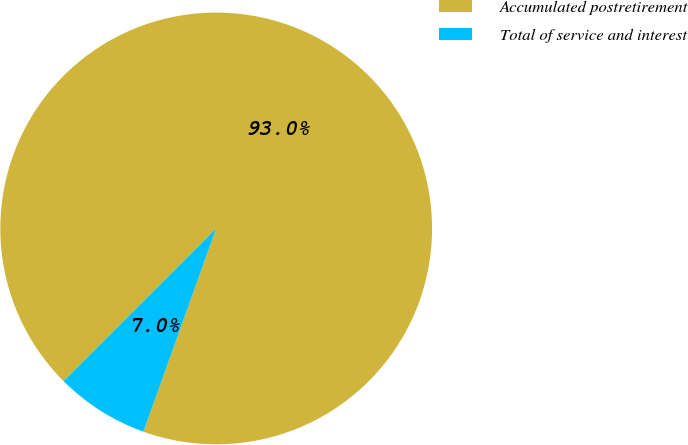<chart> <loc_0><loc_0><loc_500><loc_500><pie_chart><fcel>Accumulated postretirement<fcel>Total of service and interest<nl><fcel>92.97%<fcel>7.03%<nl></chart> 